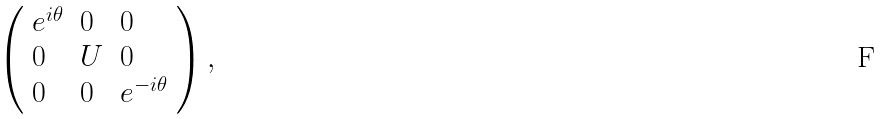Convert formula to latex. <formula><loc_0><loc_0><loc_500><loc_500>\left ( \begin{array} { l l l } { { e ^ { i \theta } } } & { 0 } & { 0 } \\ { 0 } & { U } & { 0 } \\ { 0 } & { 0 } & { { e ^ { - i \theta } } } \end{array} \right ) ,</formula> 